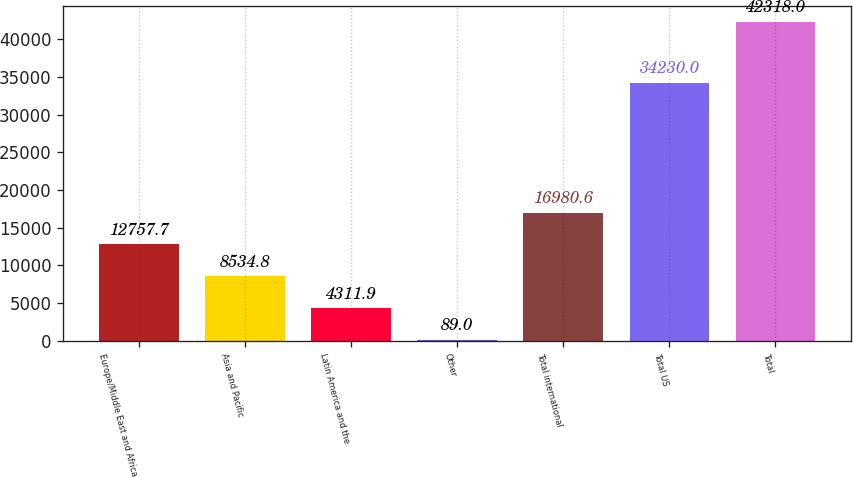Convert chart to OTSL. <chart><loc_0><loc_0><loc_500><loc_500><bar_chart><fcel>Europe/Middle East and Africa<fcel>Asia and Pacific<fcel>Latin America and the<fcel>Other<fcel>Total international<fcel>Total US<fcel>Total<nl><fcel>12757.7<fcel>8534.8<fcel>4311.9<fcel>89<fcel>16980.6<fcel>34230<fcel>42318<nl></chart> 